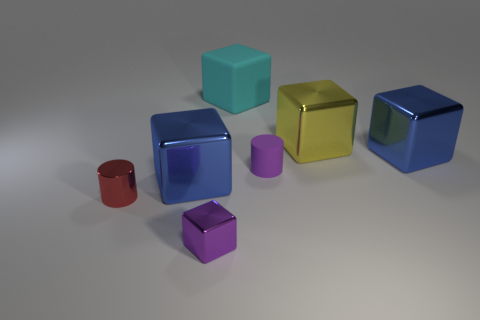Subtract all blue cubes. How many cubes are left? 3 Subtract all yellow cylinders. How many blue blocks are left? 2 Subtract 1 blocks. How many blocks are left? 4 Add 1 rubber objects. How many objects exist? 8 Subtract all yellow blocks. How many blocks are left? 4 Subtract all cyan cubes. Subtract all purple cylinders. How many cubes are left? 4 Add 3 cylinders. How many cylinders exist? 5 Subtract 0 blue cylinders. How many objects are left? 7 Subtract all cubes. How many objects are left? 2 Subtract all blue shiny things. Subtract all small shiny cubes. How many objects are left? 4 